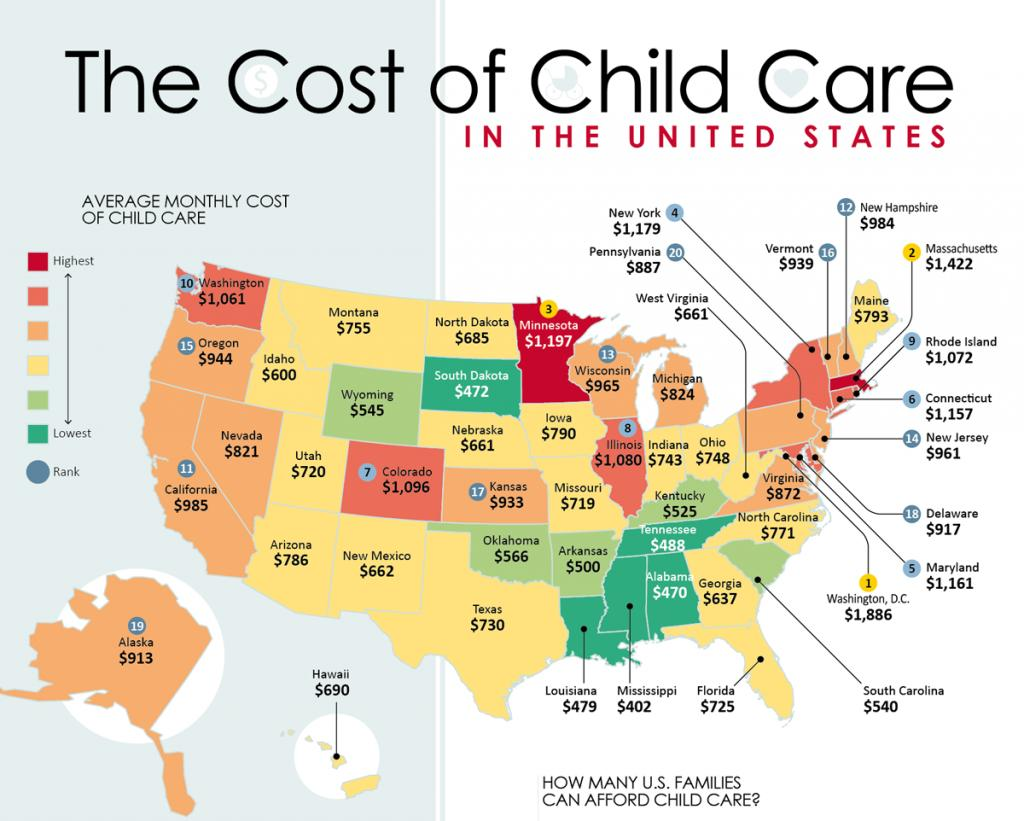Specify some key components in this picture. The state of Maine is either yellow, red, or green in color. According to recent data, the city with the highest average monthly cost of childcare is Washington, D.C. Mississippi has the lowest childcare costs among all the states in the United States. 